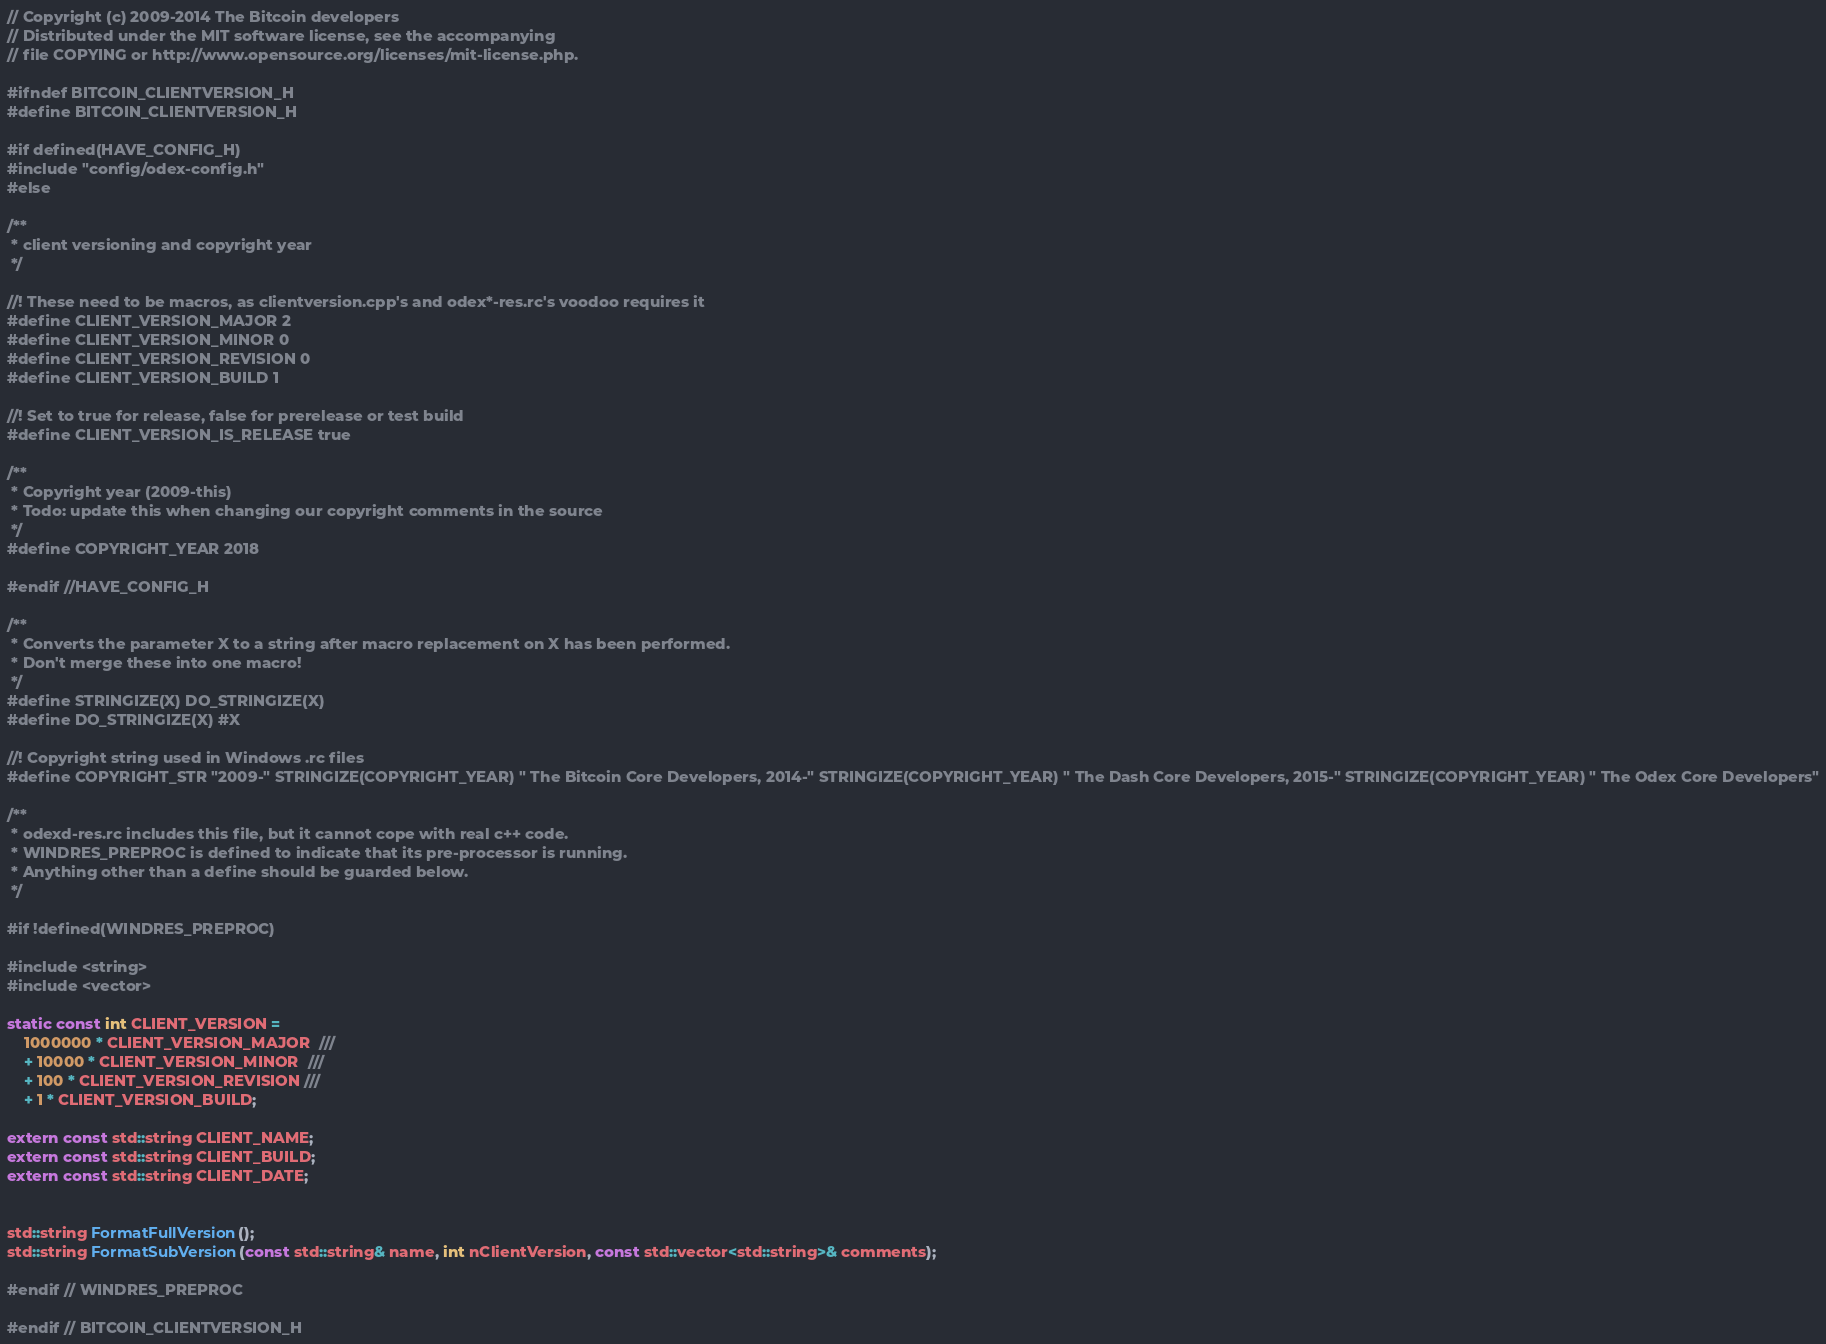<code> <loc_0><loc_0><loc_500><loc_500><_C_>// Copyright (c) 2009-2014 The Bitcoin developers
// Distributed under the MIT software license, see the accompanying
// file COPYING or http://www.opensource.org/licenses/mit-license.php.

#ifndef BITCOIN_CLIENTVERSION_H
#define BITCOIN_CLIENTVERSION_H

#if defined(HAVE_CONFIG_H)
#include "config/odex-config.h"
#else

/**
 * client versioning and copyright year
 */

//! These need to be macros, as clientversion.cpp's and odex*-res.rc's voodoo requires it
#define CLIENT_VERSION_MAJOR 2
#define CLIENT_VERSION_MINOR 0
#define CLIENT_VERSION_REVISION 0
#define CLIENT_VERSION_BUILD 1

//! Set to true for release, false for prerelease or test build
#define CLIENT_VERSION_IS_RELEASE true

/**
 * Copyright year (2009-this)
 * Todo: update this when changing our copyright comments in the source
 */
#define COPYRIGHT_YEAR 2018

#endif //HAVE_CONFIG_H

/**
 * Converts the parameter X to a string after macro replacement on X has been performed.
 * Don't merge these into one macro!
 */
#define STRINGIZE(X) DO_STRINGIZE(X)
#define DO_STRINGIZE(X) #X

//! Copyright string used in Windows .rc files
#define COPYRIGHT_STR "2009-" STRINGIZE(COPYRIGHT_YEAR) " The Bitcoin Core Developers, 2014-" STRINGIZE(COPYRIGHT_YEAR) " The Dash Core Developers, 2015-" STRINGIZE(COPYRIGHT_YEAR) " The Odex Core Developers"

/**
 * odexd-res.rc includes this file, but it cannot cope with real c++ code.
 * WINDRES_PREPROC is defined to indicate that its pre-processor is running.
 * Anything other than a define should be guarded below.
 */

#if !defined(WINDRES_PREPROC)

#include <string>
#include <vector>

static const int CLIENT_VERSION =
    1000000 * CLIENT_VERSION_MAJOR  ///
    + 10000 * CLIENT_VERSION_MINOR  ///
    + 100 * CLIENT_VERSION_REVISION ///
    + 1 * CLIENT_VERSION_BUILD;

extern const std::string CLIENT_NAME;
extern const std::string CLIENT_BUILD;
extern const std::string CLIENT_DATE;


std::string FormatFullVersion();
std::string FormatSubVersion(const std::string& name, int nClientVersion, const std::vector<std::string>& comments);

#endif // WINDRES_PREPROC

#endif // BITCOIN_CLIENTVERSION_H
</code> 